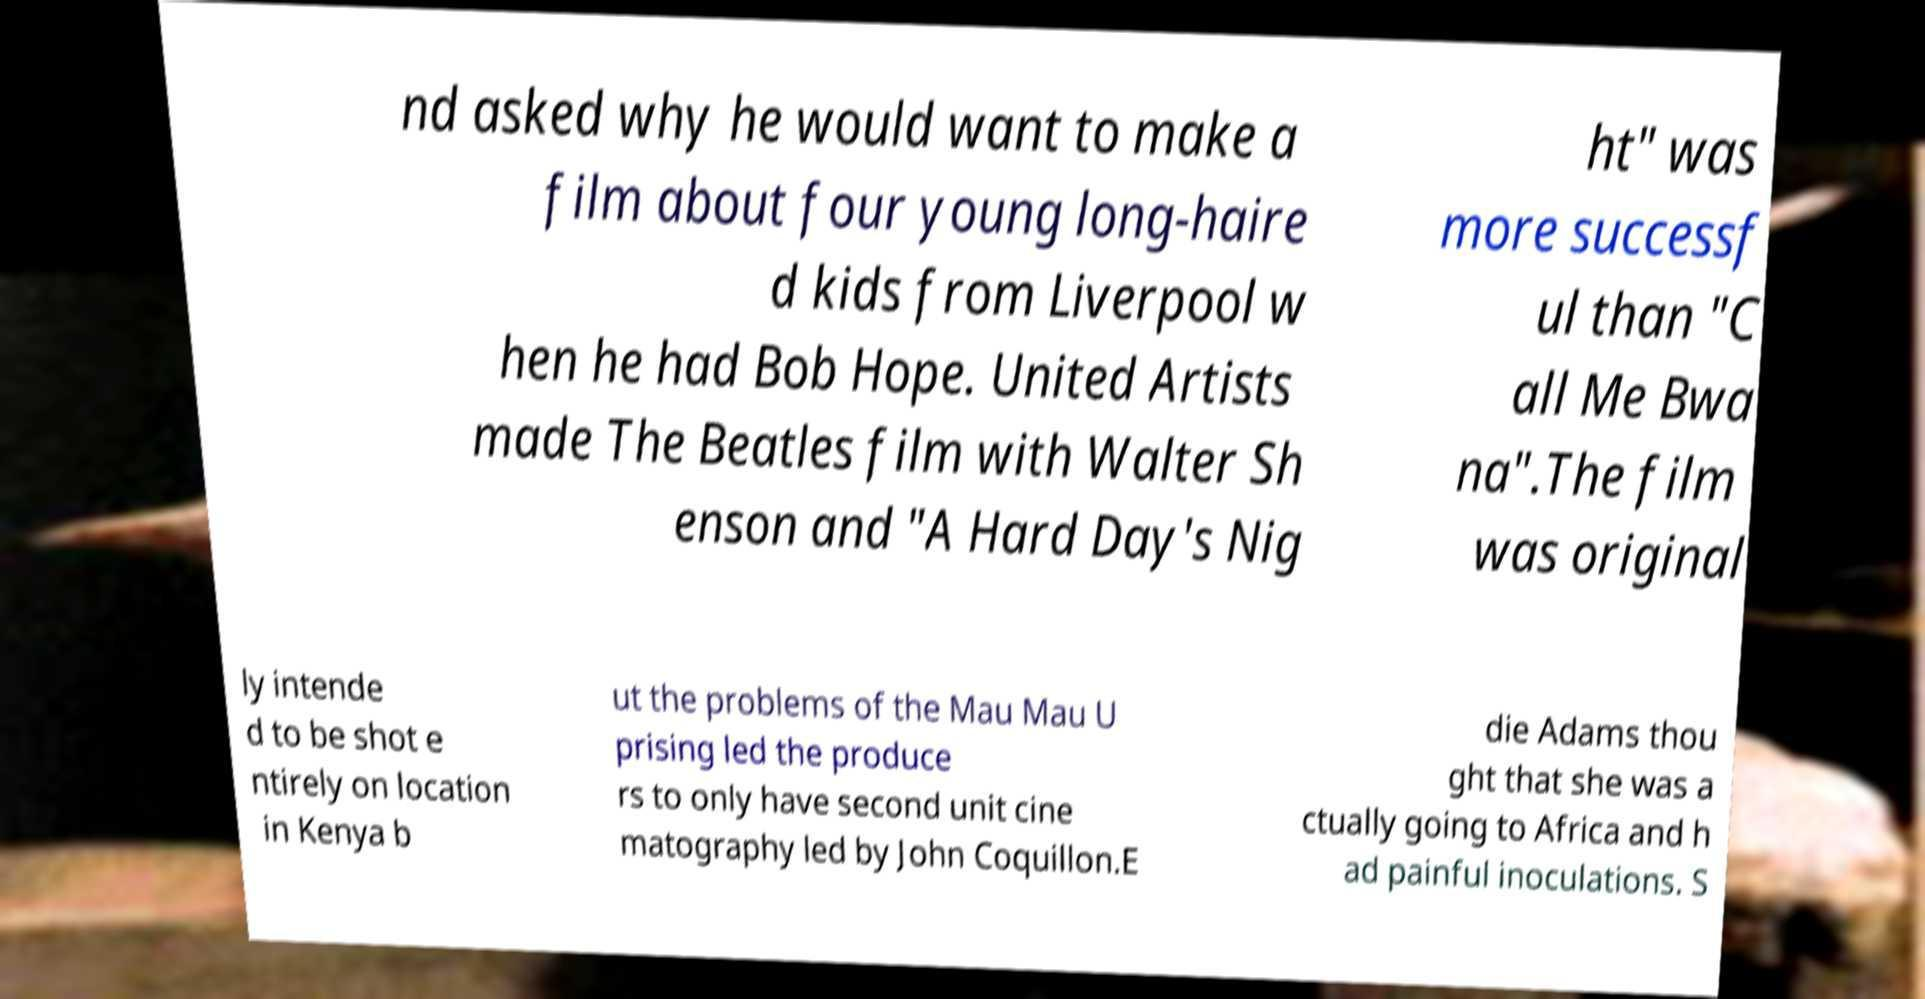Please read and relay the text visible in this image. What does it say? nd asked why he would want to make a film about four young long-haire d kids from Liverpool w hen he had Bob Hope. United Artists made The Beatles film with Walter Sh enson and "A Hard Day's Nig ht" was more successf ul than "C all Me Bwa na".The film was original ly intende d to be shot e ntirely on location in Kenya b ut the problems of the Mau Mau U prising led the produce rs to only have second unit cine matography led by John Coquillon.E die Adams thou ght that she was a ctually going to Africa and h ad painful inoculations. S 